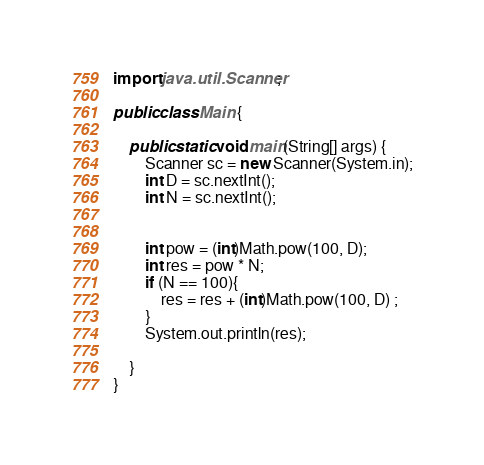<code> <loc_0><loc_0><loc_500><loc_500><_Java_>import java.util.Scanner;

public class Main {

    public static void main(String[] args) {
        Scanner sc = new Scanner(System.in);
        int D = sc.nextInt();
        int N = sc.nextInt();


        int pow = (int)Math.pow(100, D);
        int res = pow * N;
        if (N == 100){
            res = res + (int)Math.pow(100, D) ;
        }
        System.out.println(res);

    }
}
</code> 